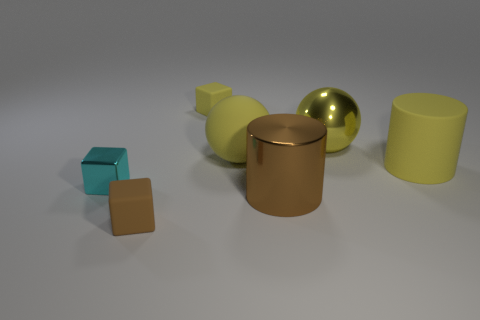There is a object that is the same color as the large shiny cylinder; what is its material?
Your answer should be very brief. Rubber. There is a large cylinder behind the cyan block; does it have the same color as the rubber sphere?
Ensure brevity in your answer.  Yes. The yellow rubber thing that is the same shape as the yellow metal object is what size?
Your answer should be compact. Large. What number of objects are large yellow matte cylinders behind the tiny brown matte block or shiny objects in front of the yellow cylinder?
Keep it short and to the point. 3. Do the brown cylinder and the yellow matte cylinder have the same size?
Provide a short and direct response. Yes. Is the number of yellow cylinders greater than the number of rubber cubes?
Your answer should be very brief. No. How many other things are there of the same color as the tiny metallic cube?
Provide a short and direct response. 0. How many things are either cyan cylinders or tiny brown matte cubes?
Your answer should be very brief. 1. There is a brown object that is to the left of the big brown shiny object; is its shape the same as the small shiny object?
Give a very brief answer. Yes. There is a matte cube that is on the right side of the small thing that is in front of the big metal cylinder; what is its color?
Offer a very short reply. Yellow. 